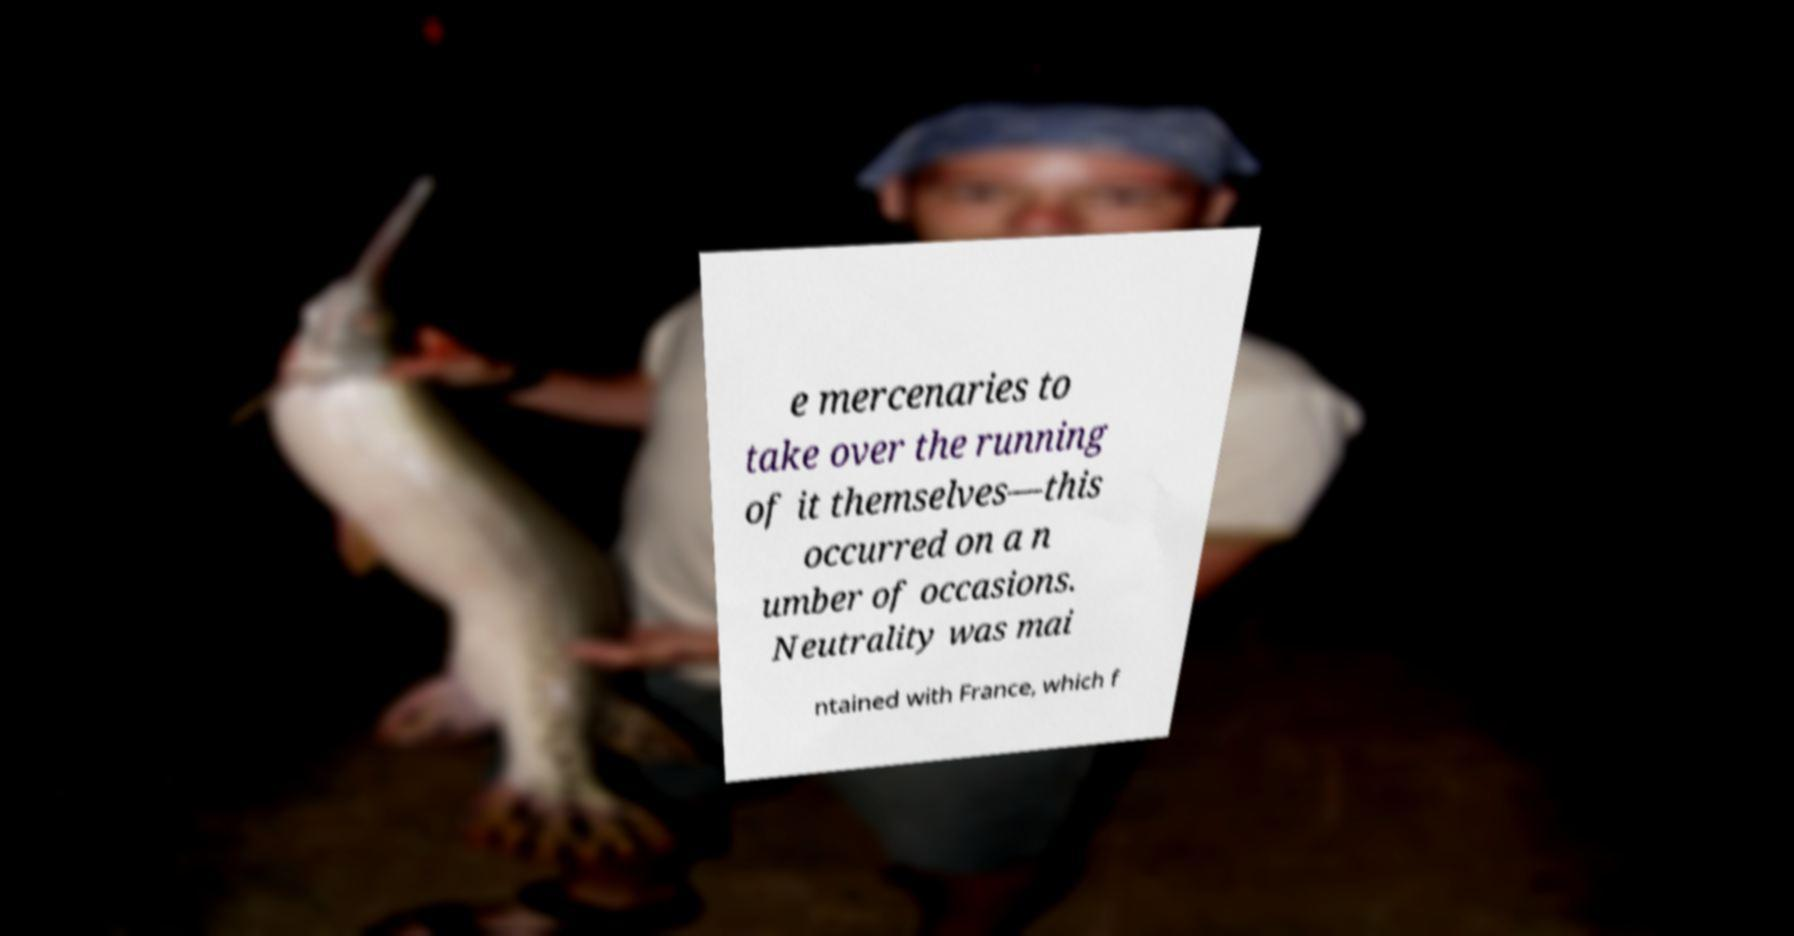For documentation purposes, I need the text within this image transcribed. Could you provide that? e mercenaries to take over the running of it themselves—this occurred on a n umber of occasions. Neutrality was mai ntained with France, which f 